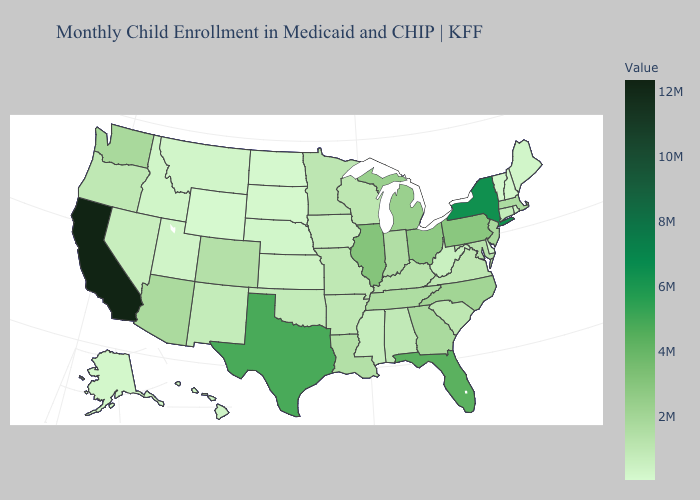Does New York have the highest value in the Northeast?
Give a very brief answer. Yes. Does New York have the highest value in the Northeast?
Quick response, please. Yes. Does Georgia have a higher value than Kansas?
Quick response, please. Yes. Which states have the lowest value in the MidWest?
Give a very brief answer. North Dakota. 